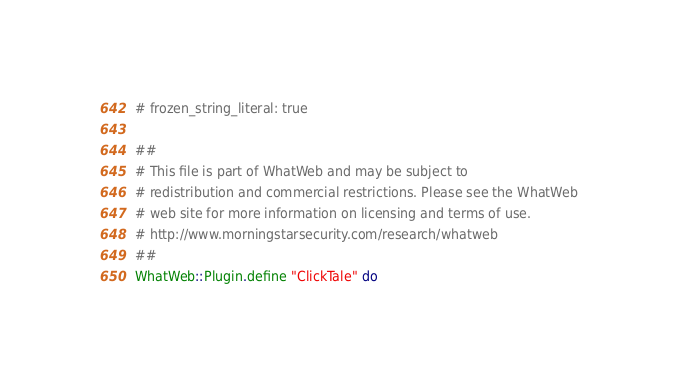Convert code to text. <code><loc_0><loc_0><loc_500><loc_500><_Ruby_># frozen_string_literal: true

##
# This file is part of WhatWeb and may be subject to
# redistribution and commercial restrictions. Please see the WhatWeb
# web site for more information on licensing and terms of use.
# http://www.morningstarsecurity.com/research/whatweb
##
WhatWeb::Plugin.define "ClickTale" do</code> 